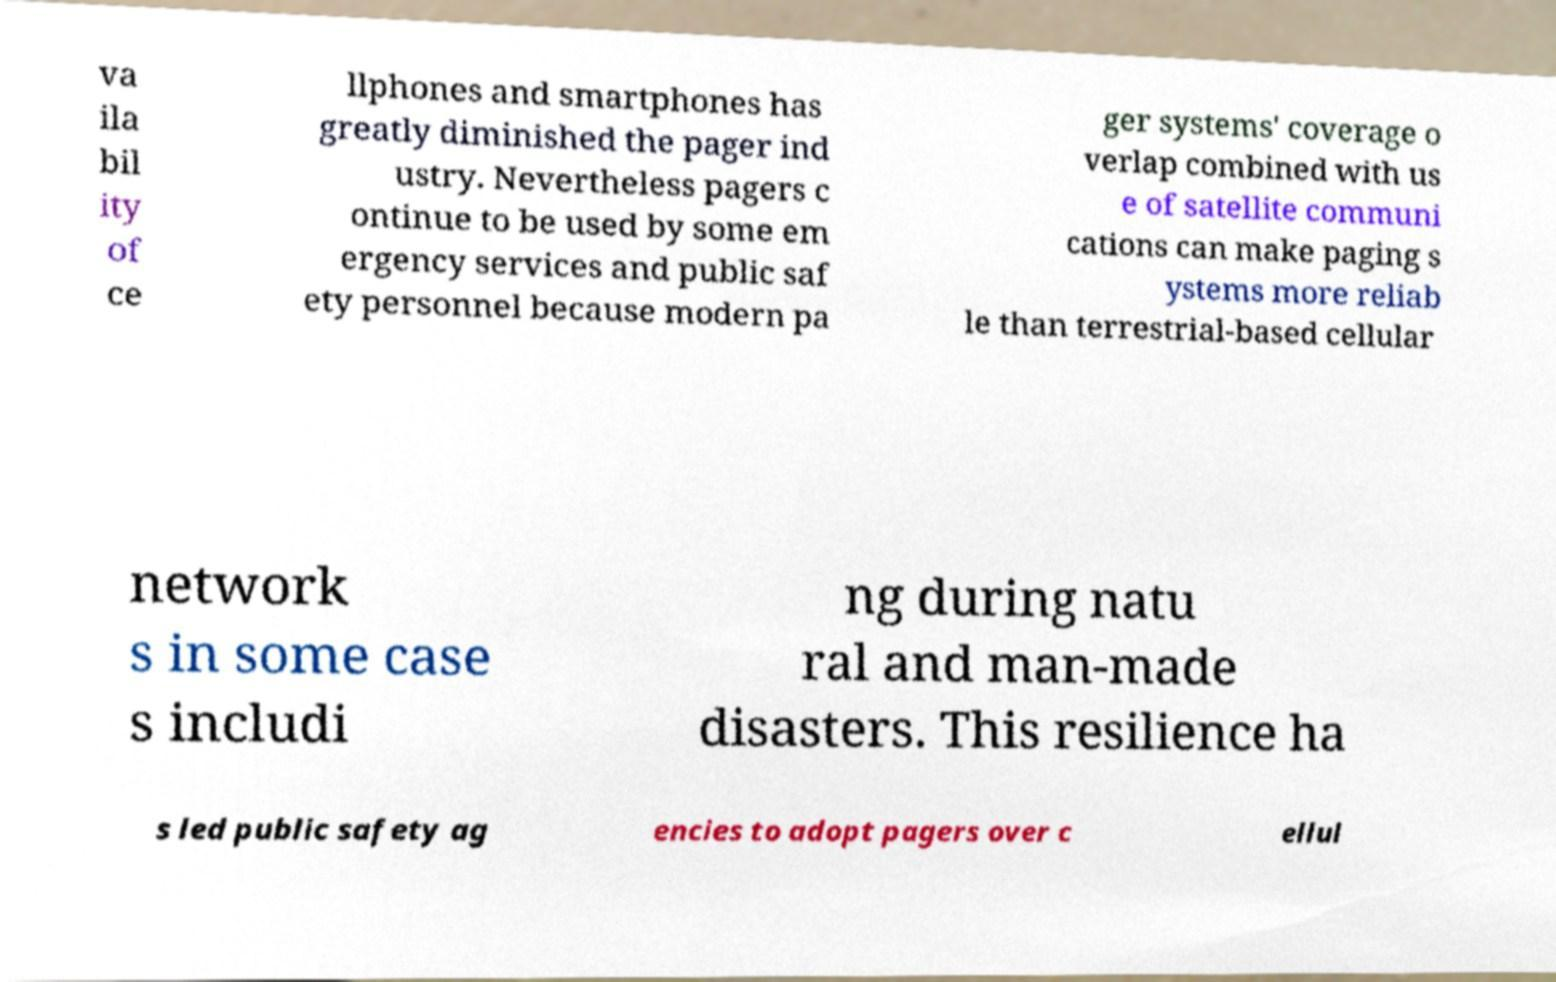Could you extract and type out the text from this image? va ila bil ity of ce llphones and smartphones has greatly diminished the pager ind ustry. Nevertheless pagers c ontinue to be used by some em ergency services and public saf ety personnel because modern pa ger systems' coverage o verlap combined with us e of satellite communi cations can make paging s ystems more reliab le than terrestrial-based cellular network s in some case s includi ng during natu ral and man-made disasters. This resilience ha s led public safety ag encies to adopt pagers over c ellul 